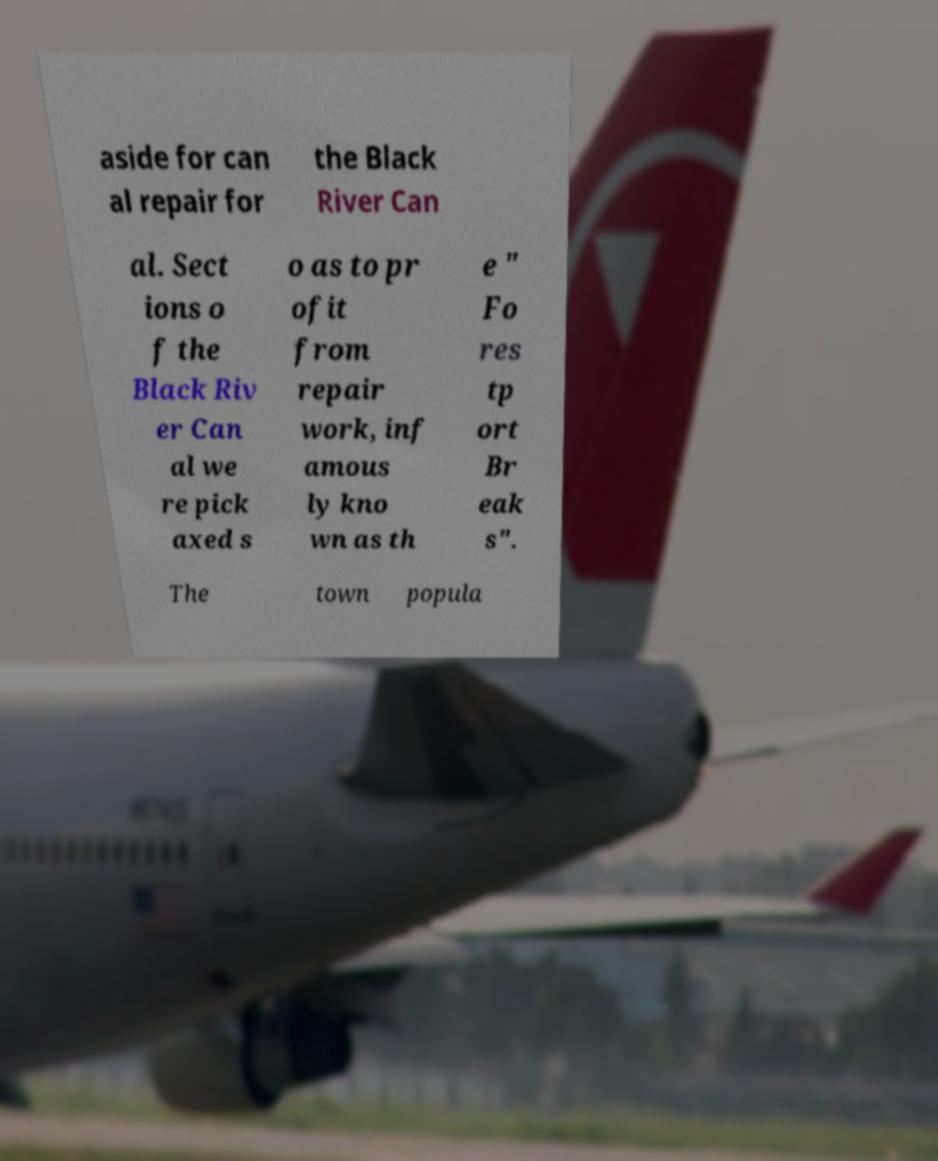Can you read and provide the text displayed in the image?This photo seems to have some interesting text. Can you extract and type it out for me? aside for can al repair for the Black River Can al. Sect ions o f the Black Riv er Can al we re pick axed s o as to pr ofit from repair work, inf amous ly kno wn as th e " Fo res tp ort Br eak s". The town popula 